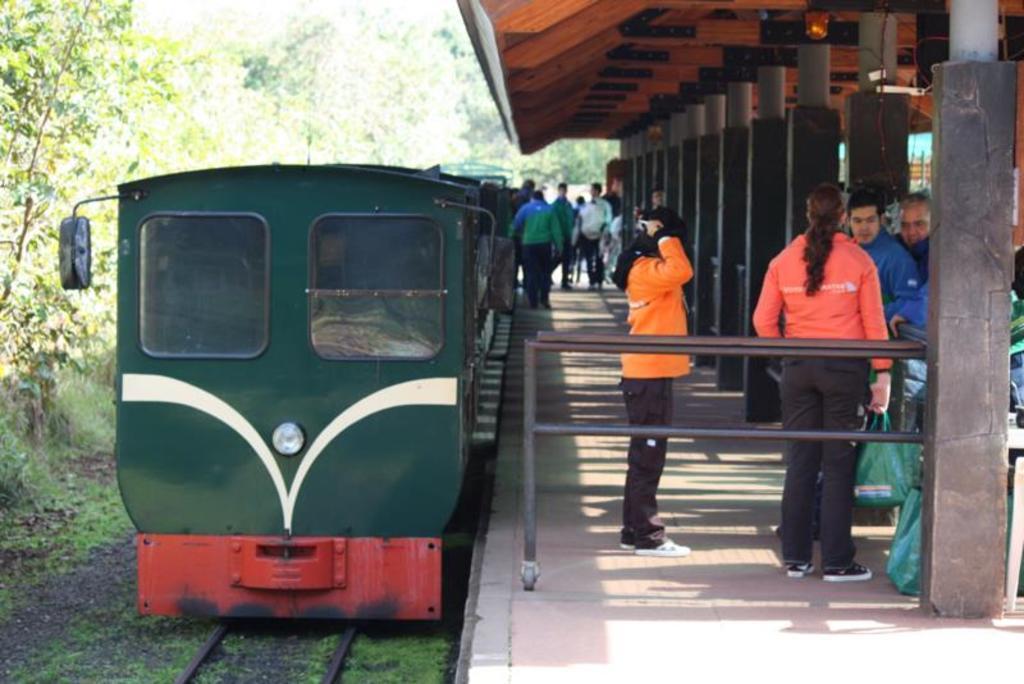How would you summarize this image in a sentence or two? In this image there is a railway track on that there is a train. Beside a sidewalk there are persons holding covers. And there is a railing, walls and roof. At the left there are trees. 